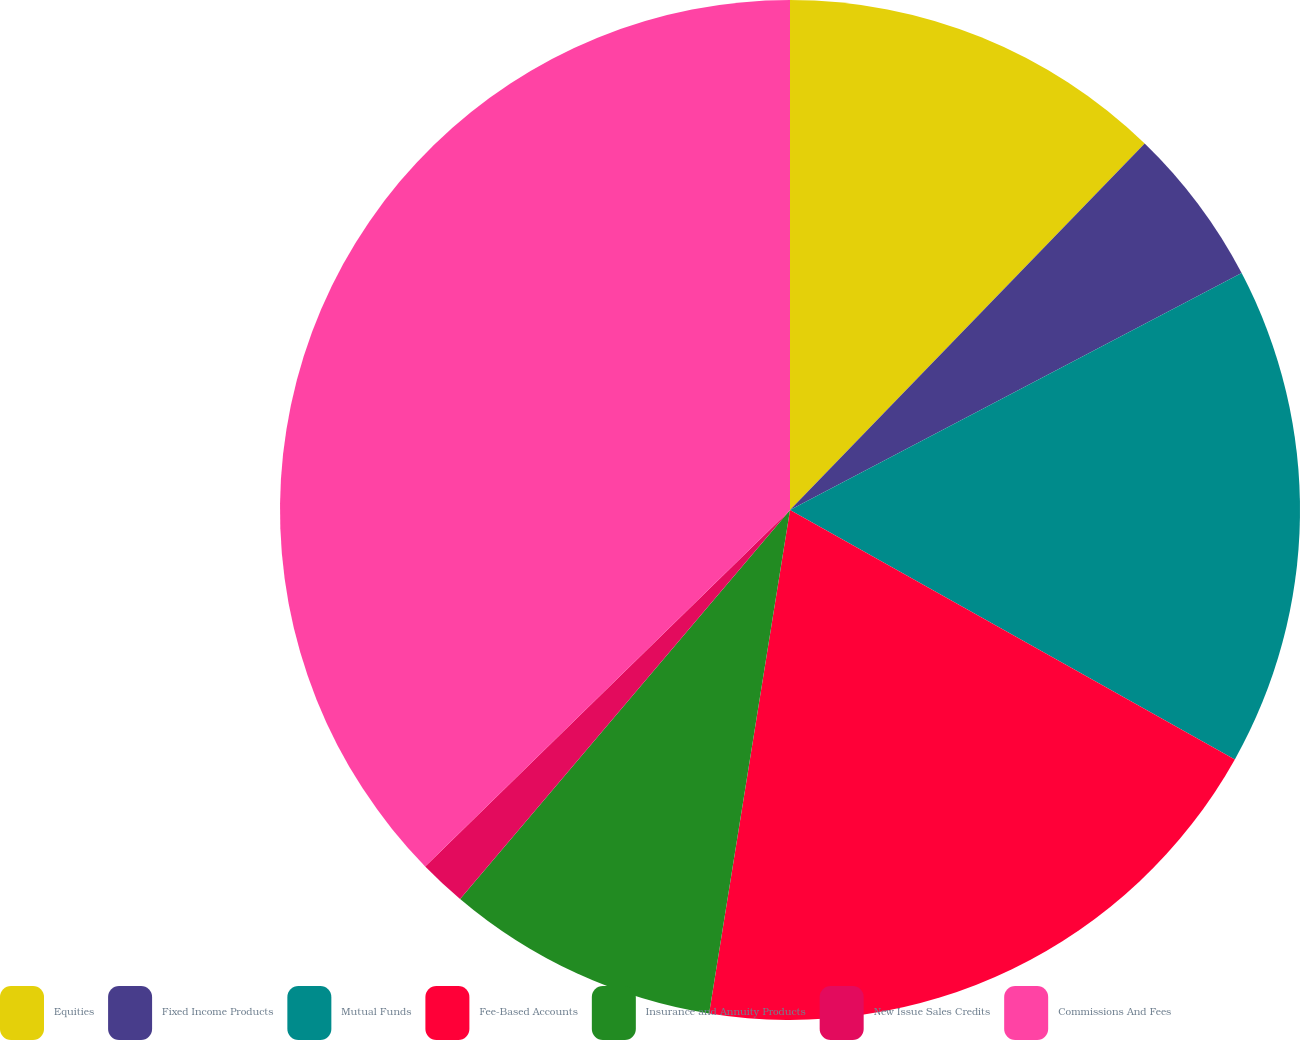Convert chart. <chart><loc_0><loc_0><loc_500><loc_500><pie_chart><fcel>Equities<fcel>Fixed Income Products<fcel>Mutual Funds<fcel>Fee-Based Accounts<fcel>Insurance and Annuity Products<fcel>New Issue Sales Credits<fcel>Commissions And Fees<nl><fcel>12.24%<fcel>5.07%<fcel>15.82%<fcel>19.4%<fcel>8.66%<fcel>1.49%<fcel>37.31%<nl></chart> 